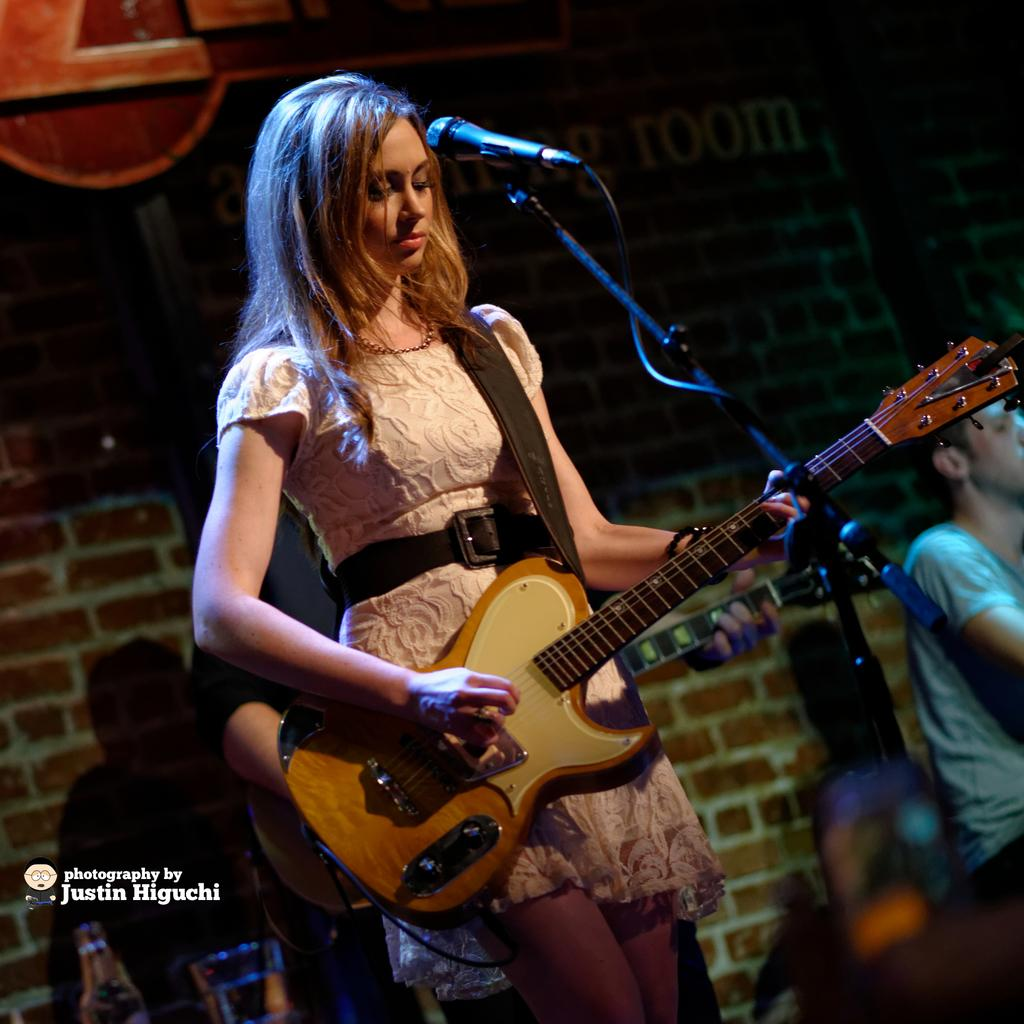Who is the main subject in the image? There is a man in the image. What is the man doing in the image? The man is standing and playing a guitar. What object is present in the image that is commonly used for amplifying sound? There is a microphone in the image. Can you tell me how the girl is playing the guitar in the image? There is no girl present in the image; it features a man playing a guitar. What type of rhythm is the tooth playing in the image? There is no tooth present in the image, and therefore no rhythm can be attributed to it. 